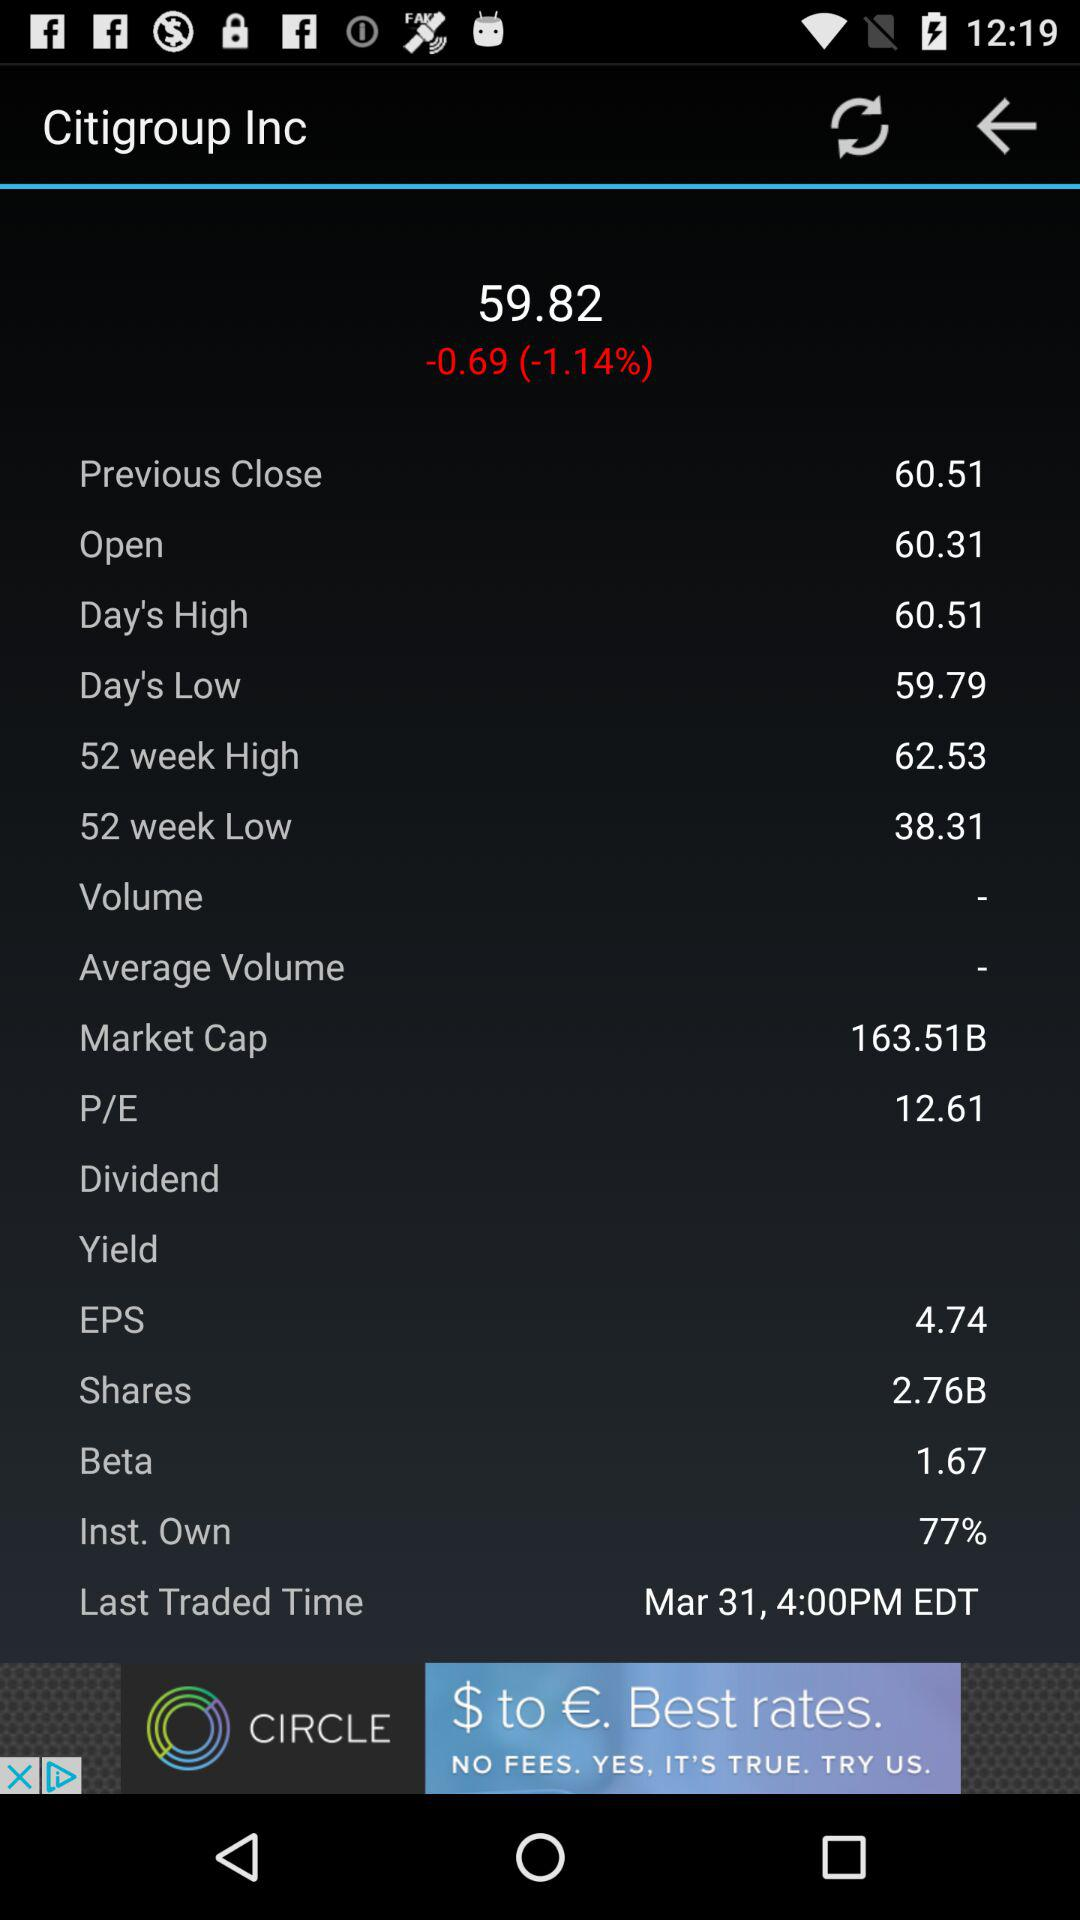What is the EPS value? The EPS value is 4.74. 